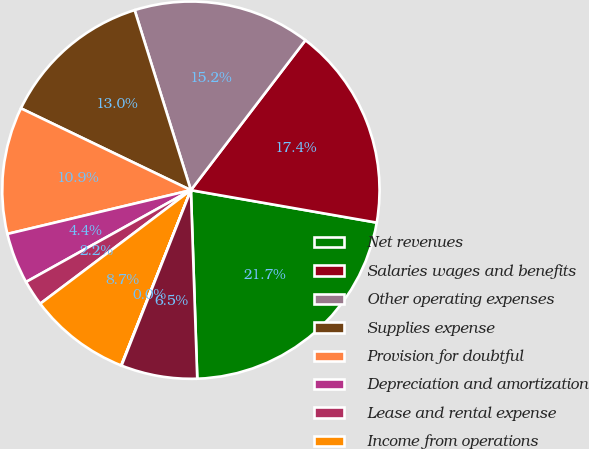Convert chart. <chart><loc_0><loc_0><loc_500><loc_500><pie_chart><fcel>Net revenues<fcel>Salaries wages and benefits<fcel>Other operating expenses<fcel>Supplies expense<fcel>Provision for doubtful<fcel>Depreciation and amortization<fcel>Lease and rental expense<fcel>Income from operations<fcel>Interest expense net<fcel>Income from continuing<nl><fcel>21.71%<fcel>17.37%<fcel>15.2%<fcel>13.04%<fcel>10.87%<fcel>4.36%<fcel>2.19%<fcel>8.7%<fcel>0.03%<fcel>6.53%<nl></chart> 